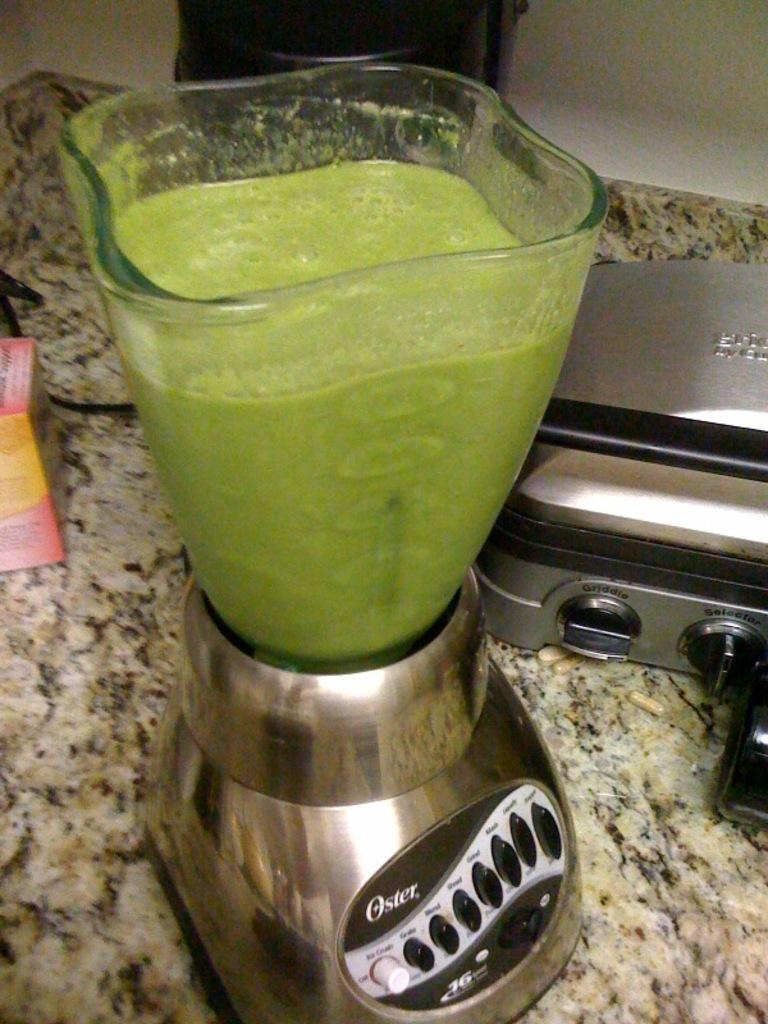<image>
Summarize the visual content of the image. A silver Oster blender that is filled with a thick green liquid. 